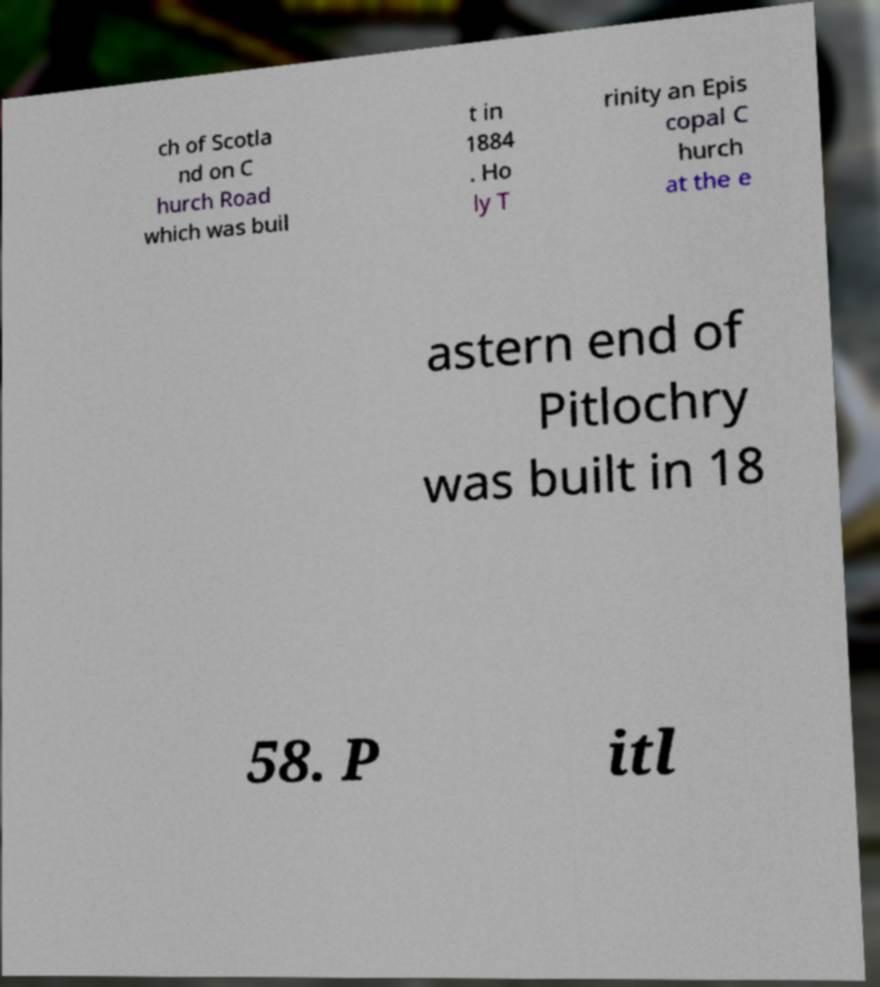Can you accurately transcribe the text from the provided image for me? ch of Scotla nd on C hurch Road which was buil t in 1884 . Ho ly T rinity an Epis copal C hurch at the e astern end of Pitlochry was built in 18 58. P itl 